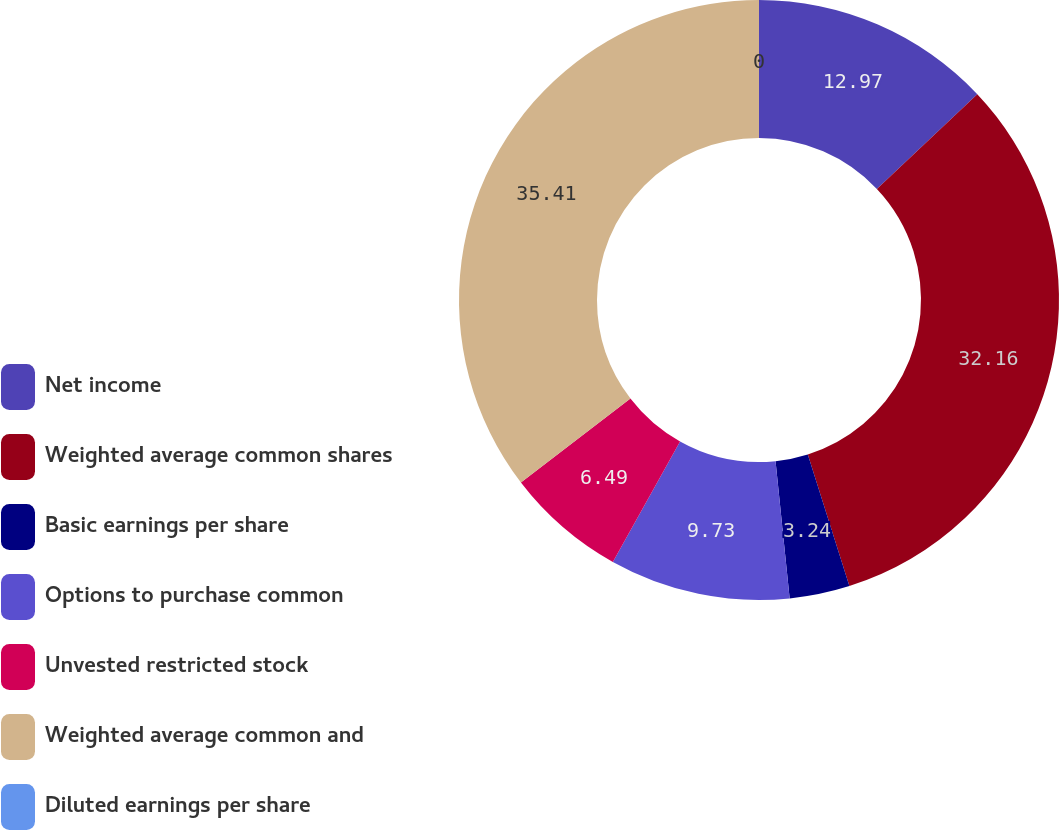<chart> <loc_0><loc_0><loc_500><loc_500><pie_chart><fcel>Net income<fcel>Weighted average common shares<fcel>Basic earnings per share<fcel>Options to purchase common<fcel>Unvested restricted stock<fcel>Weighted average common and<fcel>Diluted earnings per share<nl><fcel>12.97%<fcel>32.16%<fcel>3.24%<fcel>9.73%<fcel>6.49%<fcel>35.41%<fcel>0.0%<nl></chart> 